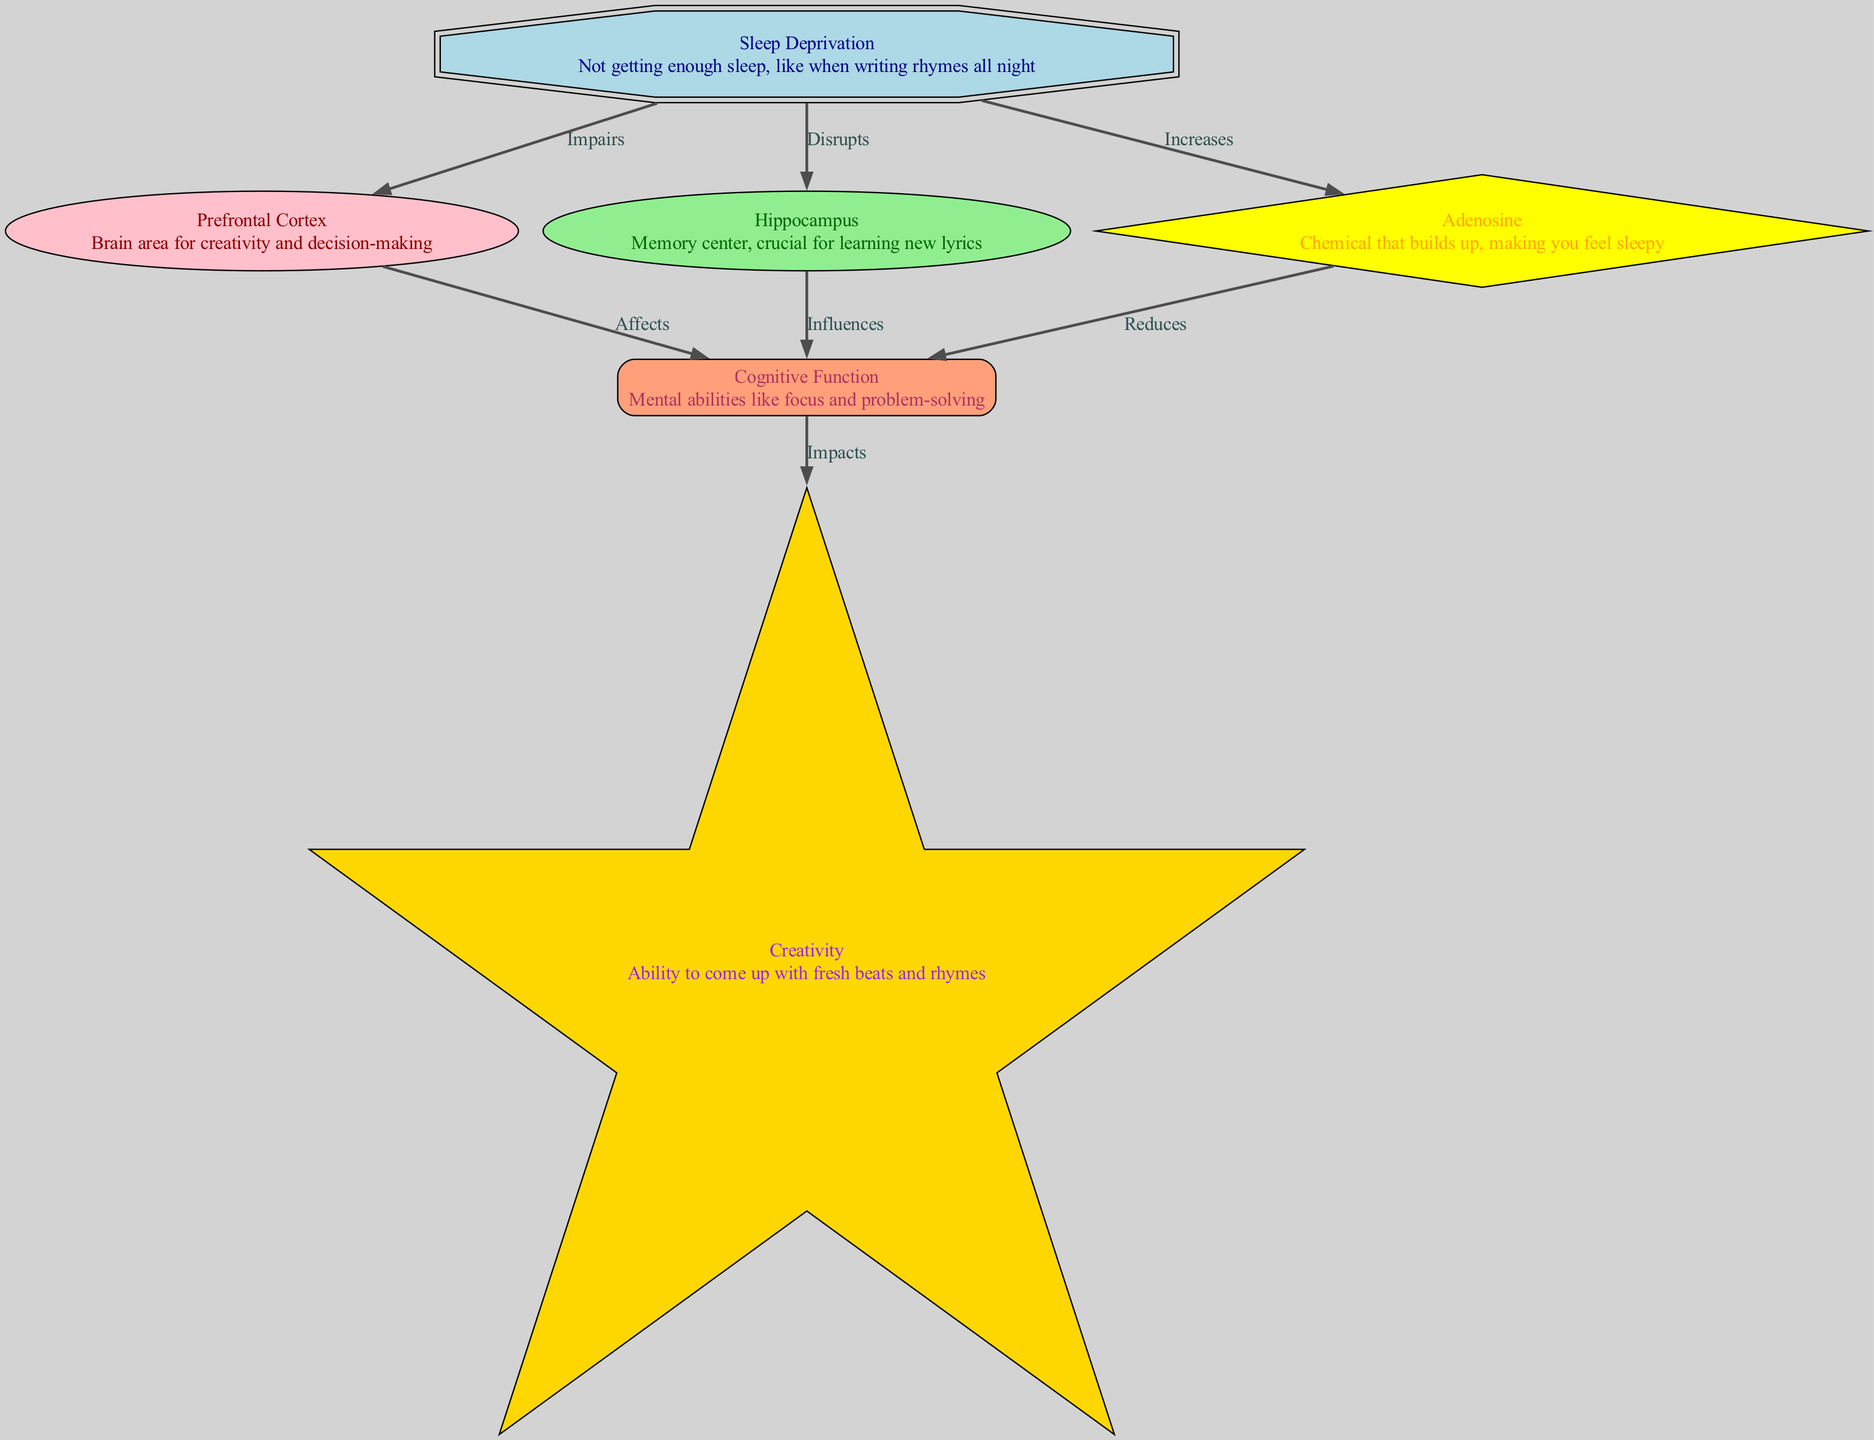What node represents not getting enough sleep? The node labeled "Sleep Deprivation" clearly represents the state of not getting enough sleep. This is shown as the starting point in the diagram.
Answer: Sleep Deprivation How does sleep deprivation affect the prefrontal cortex? The diagram shows an arrow labeled "Impairs" pointing from "Sleep Deprivation" to "Prefrontal Cortex," indicating that sleep deprivation directly impairs this brain area.
Answer: Impairs What chemical increases due to sleep deprivation? The diagram indicates an increase in the node labeled "Adenosine," which is linked to "Sleep Deprivation."
Answer: Adenosine Which brain area is crucial for learning new lyrics? The node labeled "Hippocampus" is referenced as the memory center, making it essential for learning lyrics.
Answer: Hippocampus What impact does cognitive function have on creativity? The diagram has an arrow from "Cognitive Function" to "Creativity," labeled "Impacts," indicating that cognitive function influences creative abilities.
Answer: Impacts How many nodes are there in the diagram? By counting the unique nodes listed (1-6), there are a total of six distinct nodes in the diagram.
Answer: Six Which factor reduces cognitive function? The diagram shows an arrow going from "Adenosine" to "Cognitive Function," labeled "Reduces," illustrating that increased adenosine negatively affects cognitive function.
Answer: Reduces What effect does sleep deprivation have on creativity? The diagram indirectly shows that sleep deprivation impacts creativity through both cognitive function and the prefrontal cortex; if cognitive function is reduced, then creativity is likely affected as well.
Answer: Impacts What is the relationship between the hippocampus and cognitive function? The diagram features an arrow labeled "Influences" from "Hippocampus" to "Cognitive Function," indicating that the hippocampus plays a critical role in influencing cognitive abilities.
Answer: Influences 